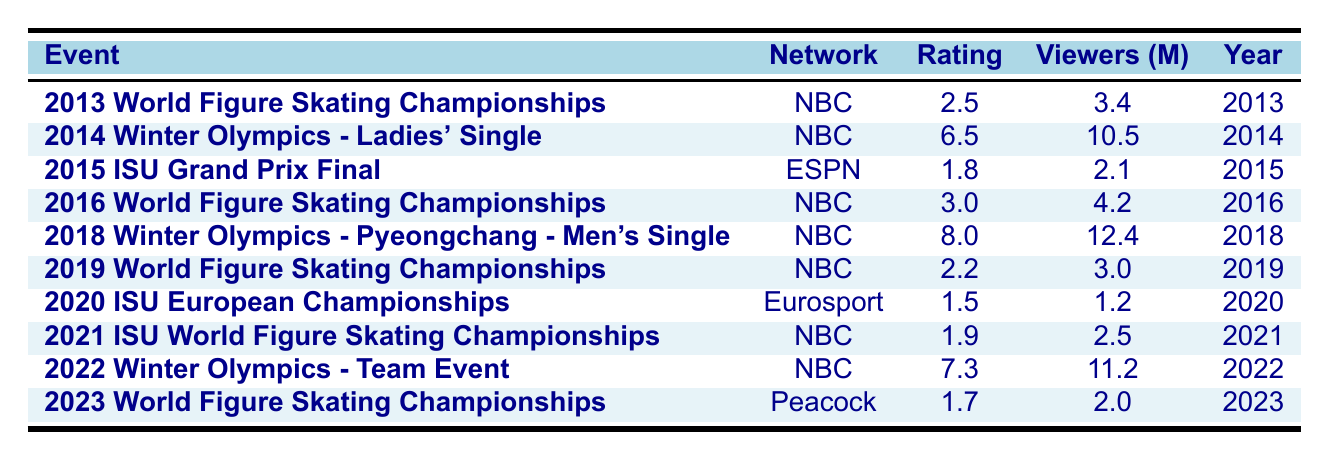What was the highest viewer rating recorded in the table? The highest rating is listed next to a corresponding event. Scanning through the "Rating" column, the highest value is 8.0, which corresponds to the "2018 Winter Olympics - Pyeongchang - Men's Single".
Answer: 8.0 What event had the lowest number of viewers? By examining the "Viewers (M)" column, the lowest value is 1.2, which is associated with the "2020 ISU European Championships".
Answer: 1.2 How many events had viewer ratings above 5.0? Looking through the "Rating" column, the events with ratings above 5.0 are: "2014 Winter Olympics - Ladies' Single" (6.5), "2018 Winter Olympics - Pyeongchang - Men's Single" (8.0), and "2022 Winter Olympics - Team Event" (7.3). This counts as 3 events.
Answer: 3 Which network aired the 2022 Winter Olympics - Team Event? The "Network" column shows that the "2022 Winter Olympics - Team Event" is associated with NBC.
Answer: NBC What is the average rating for all the NBC events? To find the average rating for NBC events, we first identify those events: "2013 World Figure Skating Championships" (2.5), "2014 Winter Olympics - Ladies' Single" (6.5), "2016 World Figure Skating Championships" (3.0), "2018 Winter Olympics - Pyeongchang - Men's Single" (8.0), "2019 World Figure Skating Championships" (2.2), "2021 ISU World Figure Skating Championships" (1.9), "2022 Winter Olympics - Team Event" (7.3). Adding these ratings gives us (2.5 + 6.5 + 3.0 + 8.0 + 2.2 + 1.9 + 7.3) = 31.4. There are 7 NBC events, so the average is 31.4/7 ≈ 4.49.
Answer: 4.49 Did any event on Eurosport have a higher rating than any event on NBC? The only event aired on Eurosport is the "2020 ISU European Championships" with a rating of 1.5. Comparing this to NBC's events, the lowest NBC rating is 1.9, which is higher than 1.5, indicating that Eurosport did not have a higher rating than NBC.
Answer: No What percentage of the events listed had ratings below 2.0? The events with ratings below 2.0 are: "2015 ISU Grand Prix Final" (1.8), "2020 ISU European Championships" (1.5), and "2021 ISU World Figure Skating Championships" (1.9). This totals 3 events out of 10. To find the percentage, we use the formula (3/10) * 100 = 30%.
Answer: 30% Which year had the highest viewer count for a figure skating broadcast? Scanning the "Viewers (M)" column, the highest viewer count is 12.4, associated with the "2018 Winter Olympics - Pyeongchang - Men's Single". Thus, the year is 2018.
Answer: 2018 How many events took place after the year 2018? Identifying the events after 2018, we find: "2019 World Figure Skating Championships", "2020 ISU European Championships", "2021 ISU World Figure Skating Championships", "2022 Winter Olympics - Team Event", and "2023 World Figure Skating Championships". This results in 5 events total.
Answer: 5 